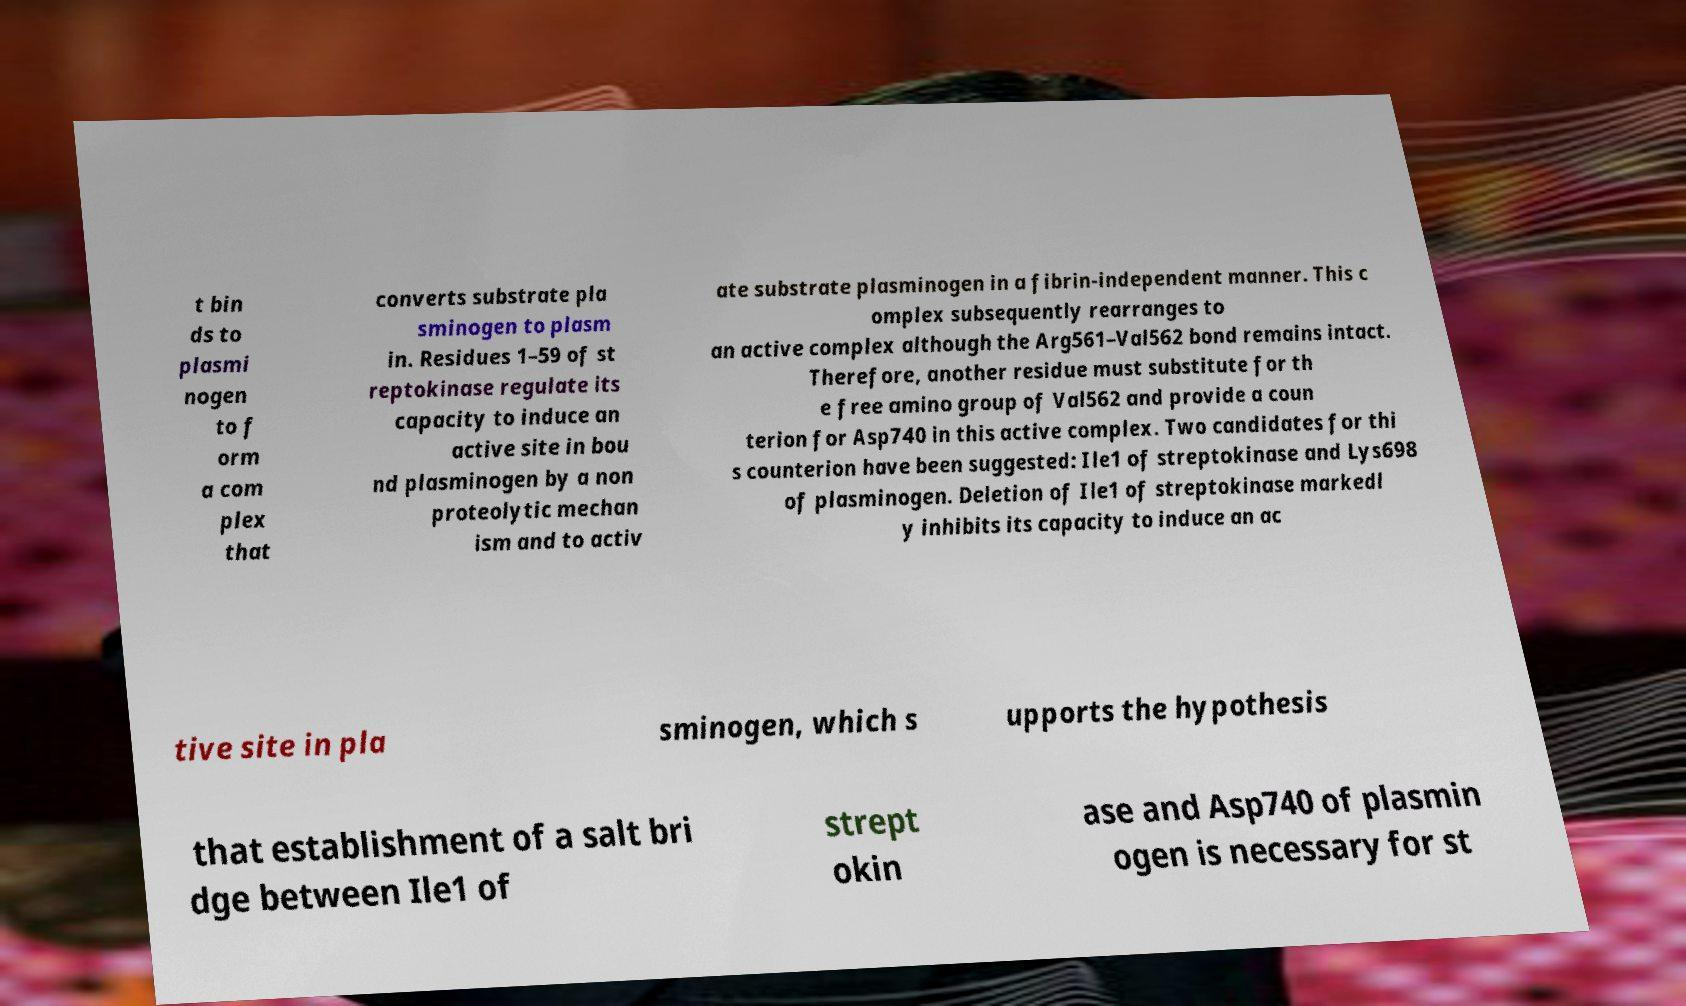There's text embedded in this image that I need extracted. Can you transcribe it verbatim? t bin ds to plasmi nogen to f orm a com plex that converts substrate pla sminogen to plasm in. Residues 1–59 of st reptokinase regulate its capacity to induce an active site in bou nd plasminogen by a non proteolytic mechan ism and to activ ate substrate plasminogen in a fibrin-independent manner. This c omplex subsequently rearranges to an active complex although the Arg561–Val562 bond remains intact. Therefore, another residue must substitute for th e free amino group of Val562 and provide a coun terion for Asp740 in this active complex. Two candidates for thi s counterion have been suggested: Ile1 of streptokinase and Lys698 of plasminogen. Deletion of Ile1 of streptokinase markedl y inhibits its capacity to induce an ac tive site in pla sminogen, which s upports the hypothesis that establishment of a salt bri dge between Ile1 of strept okin ase and Asp740 of plasmin ogen is necessary for st 